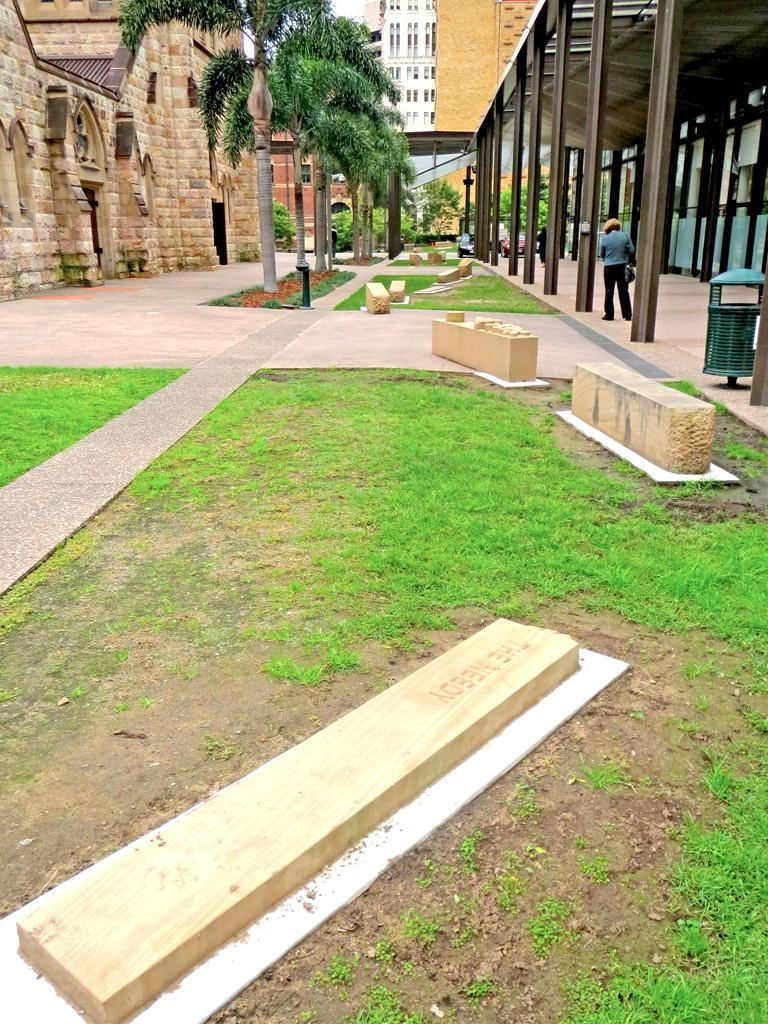What can be seen in the foreground of the image? There are headstones and grassland in the foreground in the foreground of the image. What is visible in the background of the image? There are buildings, trees, sheds, a person, and the sky visible in the background of the image. Can you describe the vegetation in the image? There is grassland in the foreground and trees in the background of the image. What type of structures can be seen in the background? There are buildings and sheds in the background of the image. Is there any indication of the weather in the image? The sky is visible in the background of the image, but no specific weather conditions can be determined from the image alone. What type of chair is the person sitting on in the image? There is no person sitting on a chair in the image; the person is standing in the background. What color is the marble used for the headstones in the image? There is no mention of marble in the image; the headstones are not described in terms of their material. 